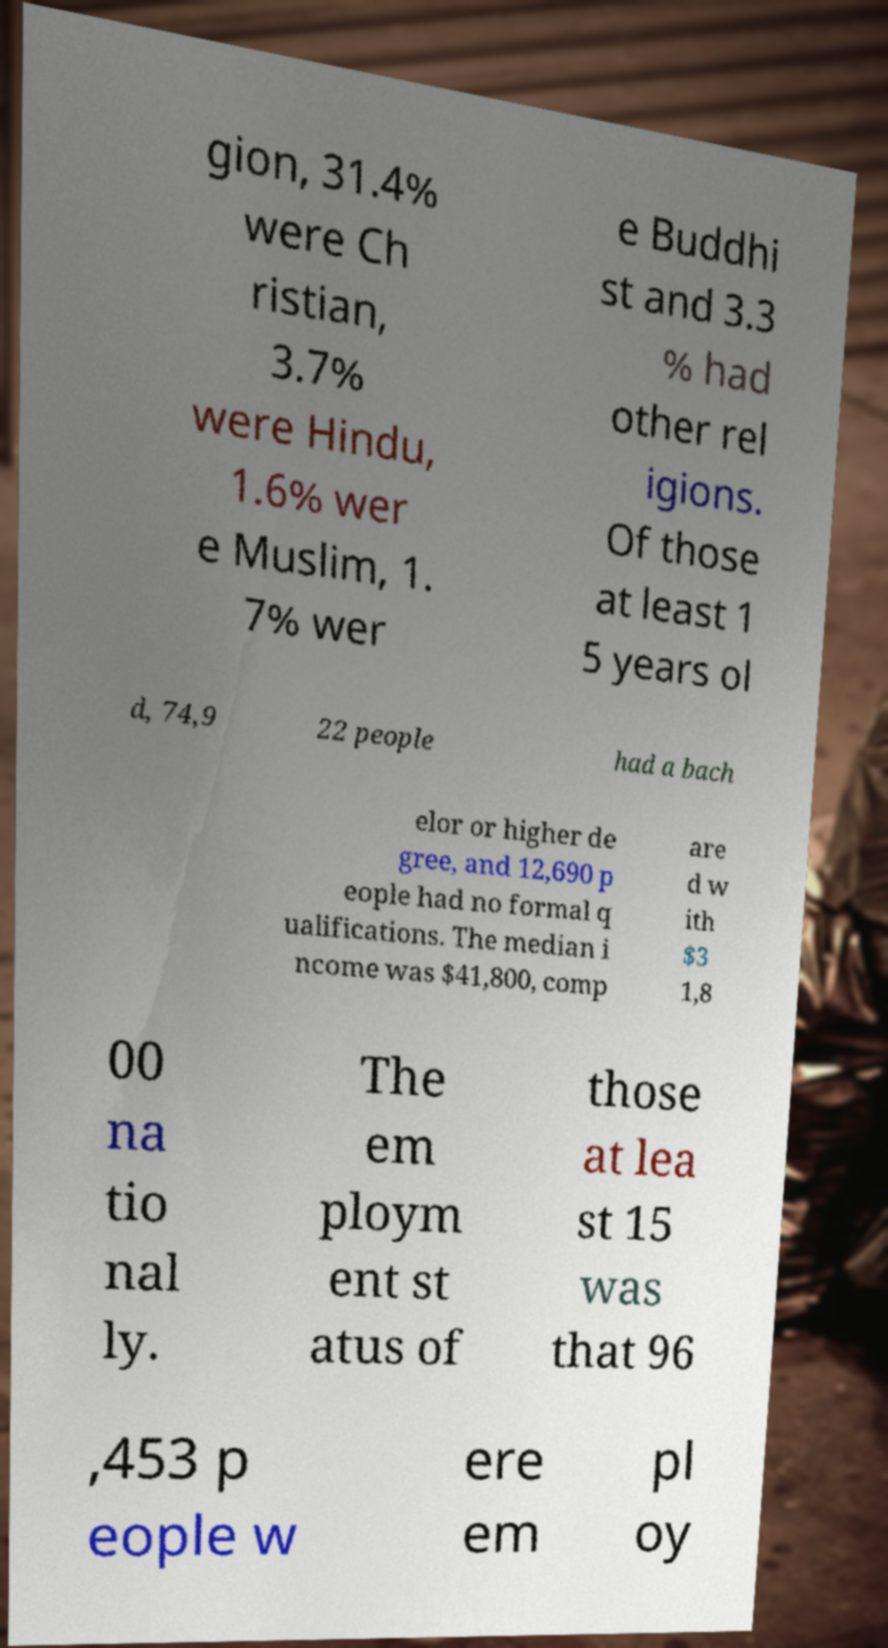Please identify and transcribe the text found in this image. gion, 31.4% were Ch ristian, 3.7% were Hindu, 1.6% wer e Muslim, 1. 7% wer e Buddhi st and 3.3 % had other rel igions. Of those at least 1 5 years ol d, 74,9 22 people had a bach elor or higher de gree, and 12,690 p eople had no formal q ualifications. The median i ncome was $41,800, comp are d w ith $3 1,8 00 na tio nal ly. The em ploym ent st atus of those at lea st 15 was that 96 ,453 p eople w ere em pl oy 